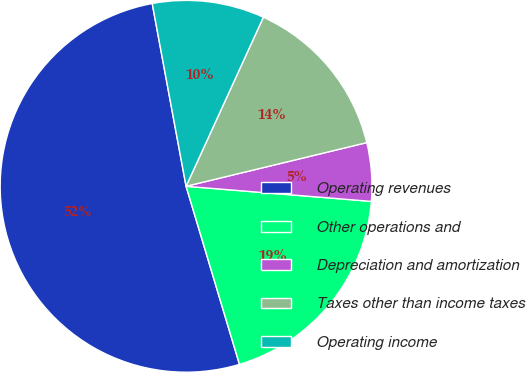Convert chart to OTSL. <chart><loc_0><loc_0><loc_500><loc_500><pie_chart><fcel>Operating revenues<fcel>Other operations and<fcel>Depreciation and amortization<fcel>Taxes other than income taxes<fcel>Operating income<nl><fcel>51.72%<fcel>19.07%<fcel>5.07%<fcel>14.4%<fcel>9.74%<nl></chart> 